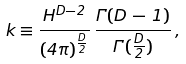Convert formula to latex. <formula><loc_0><loc_0><loc_500><loc_500>k \equiv \frac { H ^ { D - 2 } } { ( 4 \pi ) ^ { \frac { D } 2 } } \, \frac { \Gamma ( D \, - \, 1 ) } { \Gamma ( \frac { D } 2 ) } \, ,</formula> 